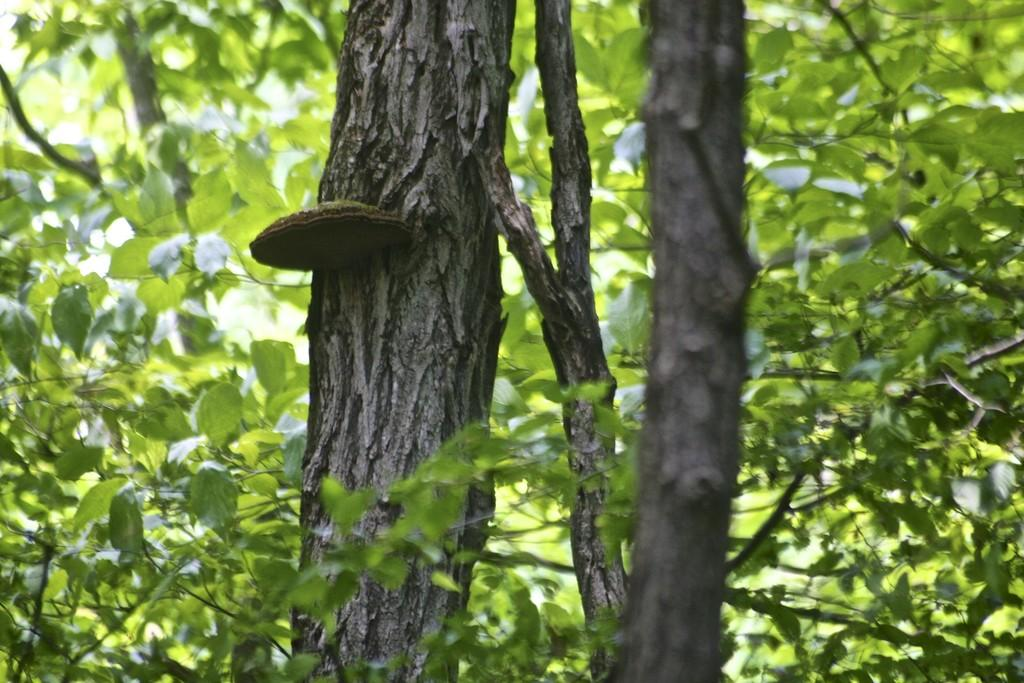What is the main object in the foreground of the image? There is a tree branch in the image. What can be seen in the background of the image? There are many plants visible behind the tree branch. What type of nut is being used in the war depicted in the image? There is no war or nut present in the image; it features a tree branch and plants. 